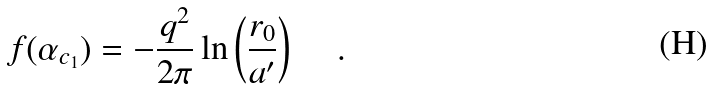<formula> <loc_0><loc_0><loc_500><loc_500>f ( \alpha _ { c _ { 1 } } ) = - \frac { q ^ { 2 } } { 2 \pi } \ln \left ( \frac { r _ { 0 } } { a ^ { \prime } } \right ) \, \quad .</formula> 